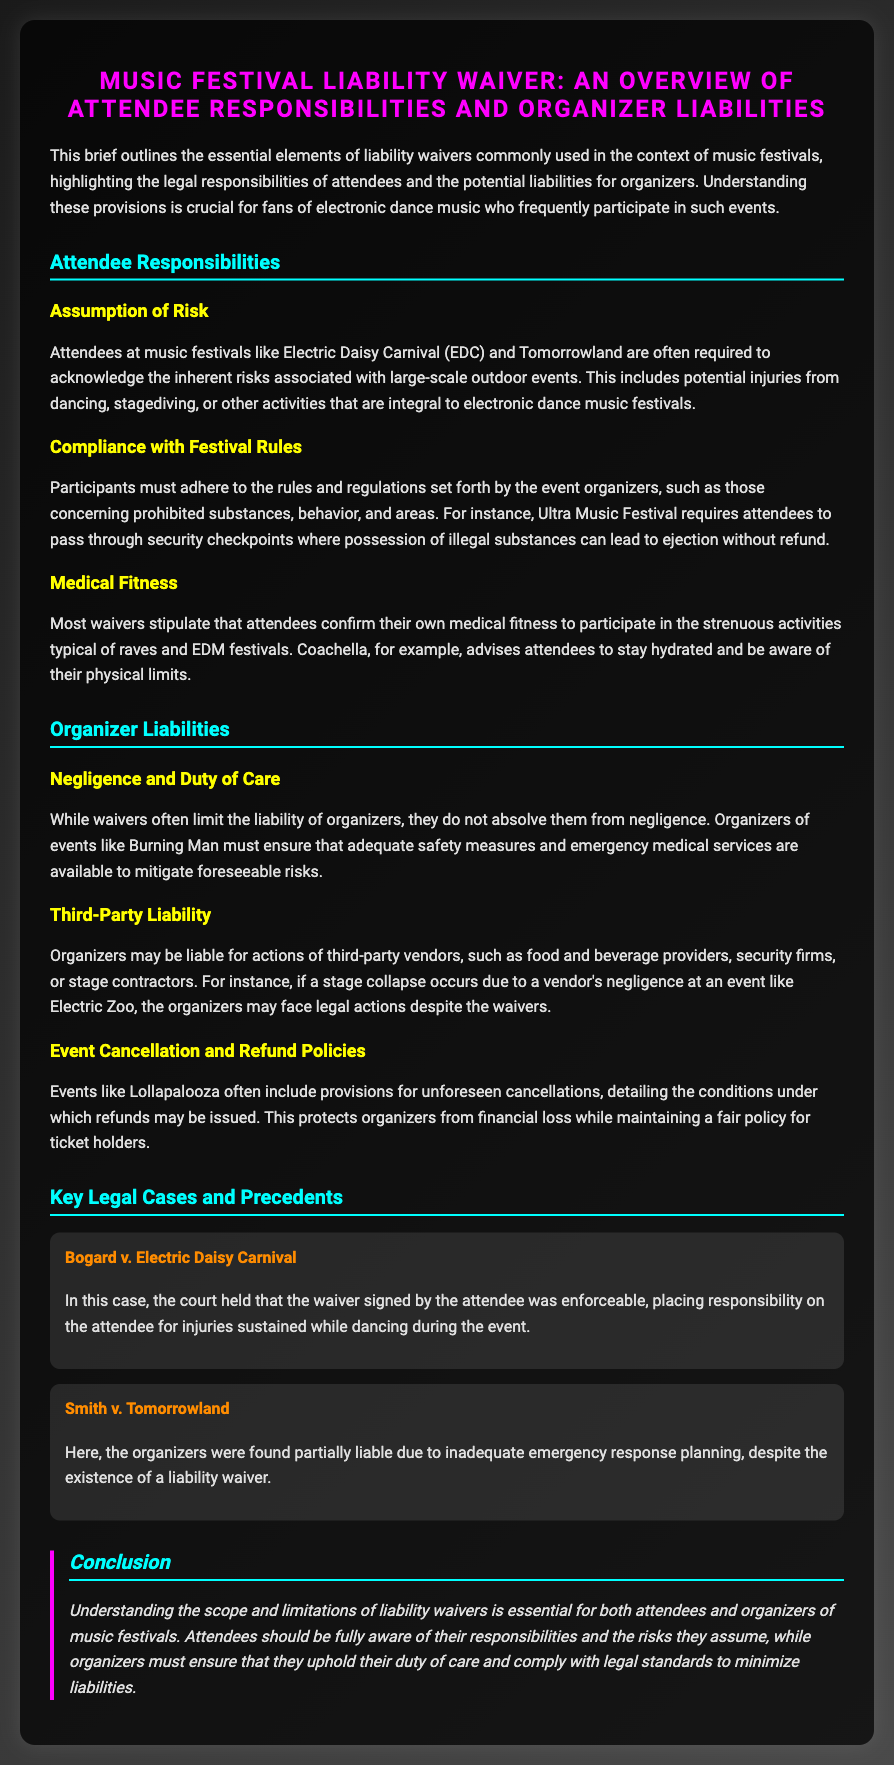what is the title of the document? The title of the document is prominently displayed at the top and provides an overview of the content discussed within the document.
Answer: Music Festival Liability Waiver: An Overview of Attendee Responsibilities and Organizer Liabilities what is one example of an attendee responsibility? The document lists several responsibilities of attendees, including the assumption of inherent risks associated with large-scale outdoor events.
Answer: Assumption of Risk what is the name of a music festival mentioned in the document? The document specifically mentions several well-known music festivals as examples of events where waivers are common practices.
Answer: Electric Daisy Carnival what must attendees confirm about themselves? The document states that waivers typically require attendees to confirm their suitability to participate in physically strenuous activities.
Answer: Medical Fitness what can organizers be liable for? The document explains that organizers may incur liabilities for certain actions that are beyond their own control, such as issues involving other vendors.
Answer: Third-Party Liability who was involved in the case Bogard v. Electric Daisy Carnival? The case highlights the legal implications of liability waivers and the responsibilities of attendees at festivals.
Answer: Electric Daisy Carnival what was a key finding in Smith v. Tomorrowland? This case illustrates an instance where organizers could still be held responsible despite the presence of waivers, emphasizing the nuance in liability.
Answer: Inadequate emergency response planning how do organizers protect themselves against event cancellations? The document mentions that event organizers often have policies to mitigate financial loss in case of unexpected cancellations.
Answer: Refund Policies what is a critical takeaway from the conclusion? The conclusion summarizes the need for both attendees and organizers to understand their respective roles in the context of liability waivers at festivals.
Answer: Responsibilities and risks 